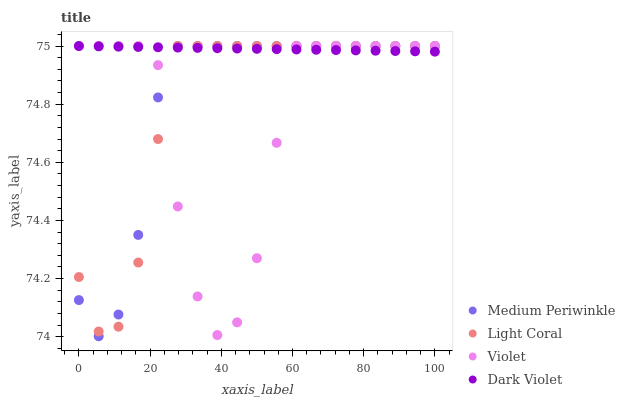Does Violet have the minimum area under the curve?
Answer yes or no. Yes. Does Dark Violet have the maximum area under the curve?
Answer yes or no. Yes. Does Medium Periwinkle have the minimum area under the curve?
Answer yes or no. No. Does Medium Periwinkle have the maximum area under the curve?
Answer yes or no. No. Is Dark Violet the smoothest?
Answer yes or no. Yes. Is Violet the roughest?
Answer yes or no. Yes. Is Medium Periwinkle the smoothest?
Answer yes or no. No. Is Medium Periwinkle the roughest?
Answer yes or no. No. Does Medium Periwinkle have the lowest value?
Answer yes or no. Yes. Does Dark Violet have the lowest value?
Answer yes or no. No. Does Violet have the highest value?
Answer yes or no. Yes. Does Violet intersect Dark Violet?
Answer yes or no. Yes. Is Violet less than Dark Violet?
Answer yes or no. No. Is Violet greater than Dark Violet?
Answer yes or no. No. 